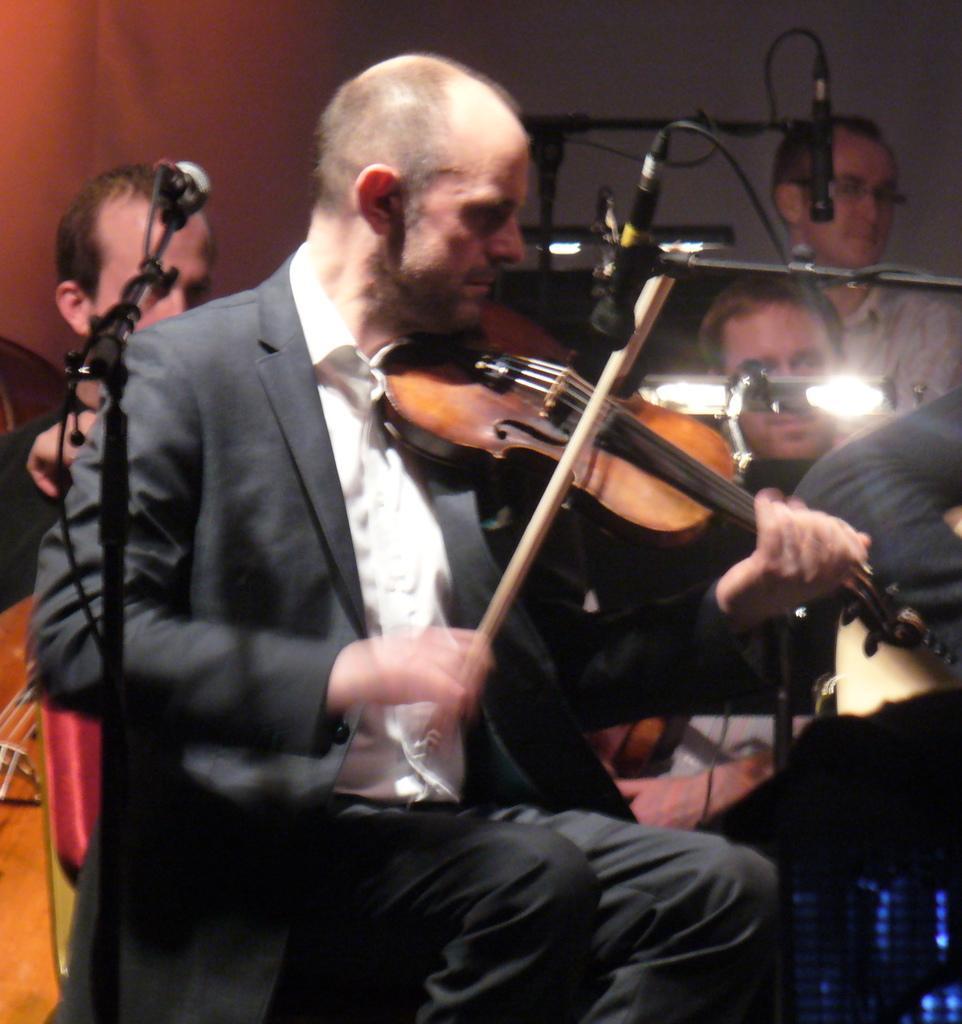In one or two sentences, can you explain what this image depicts? He is a man sitting on a chair. He holds a guitar in his hands. This is a microphone. In the background there are two people who are at left side. There is man on left side. 